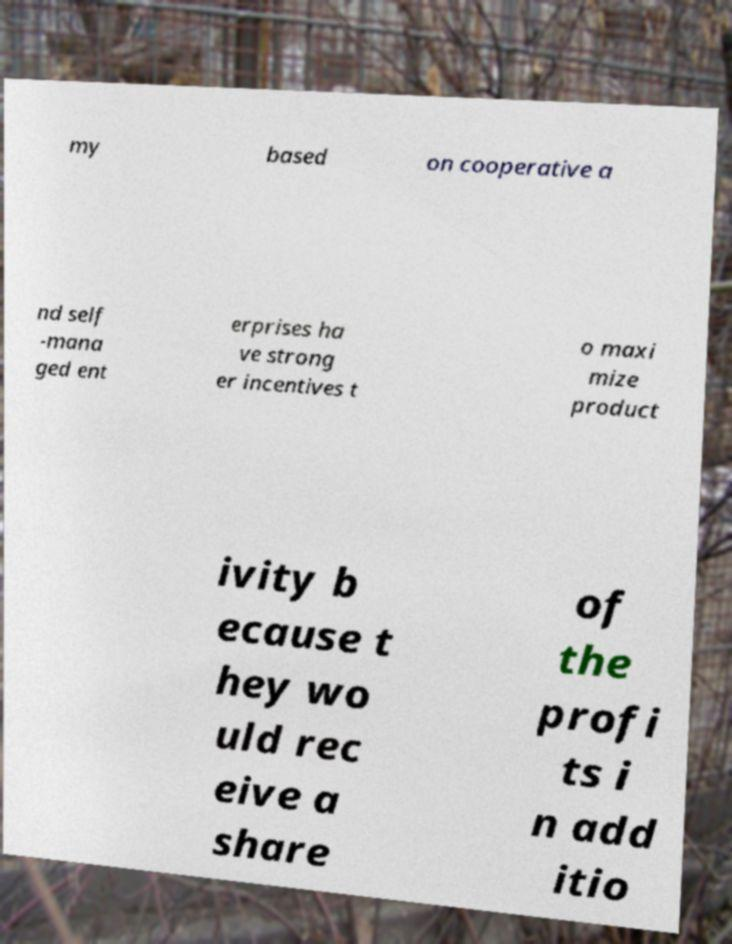For documentation purposes, I need the text within this image transcribed. Could you provide that? my based on cooperative a nd self -mana ged ent erprises ha ve strong er incentives t o maxi mize product ivity b ecause t hey wo uld rec eive a share of the profi ts i n add itio 